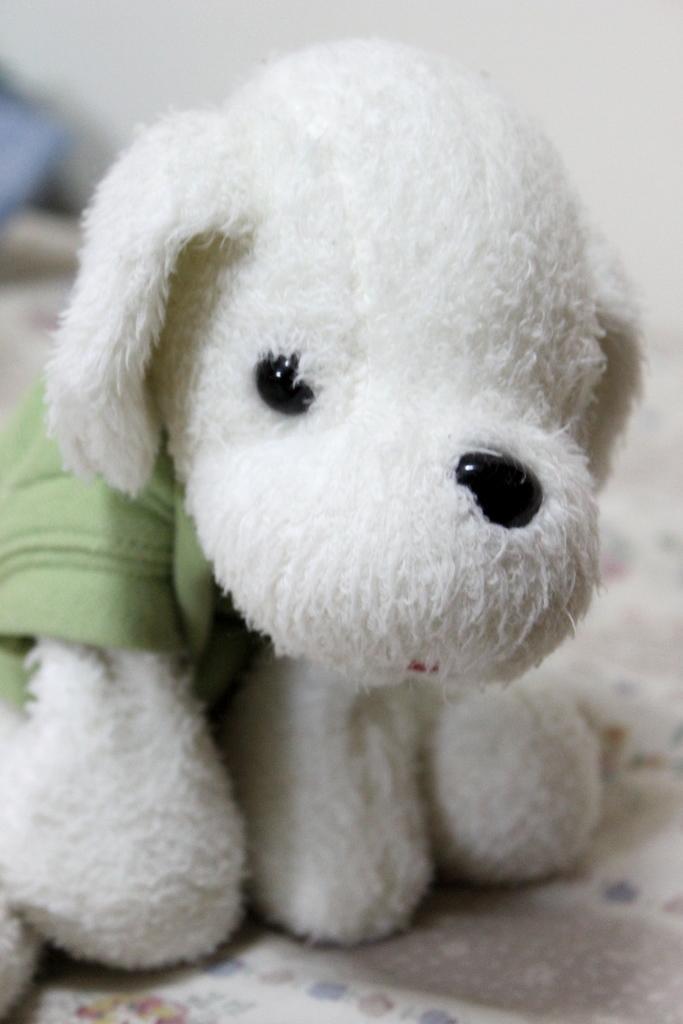In one or two sentences, can you explain what this image depicts? The picture consists of a toy, looking like a dog. The background is blurred. In the foreground there is a white cloth. 